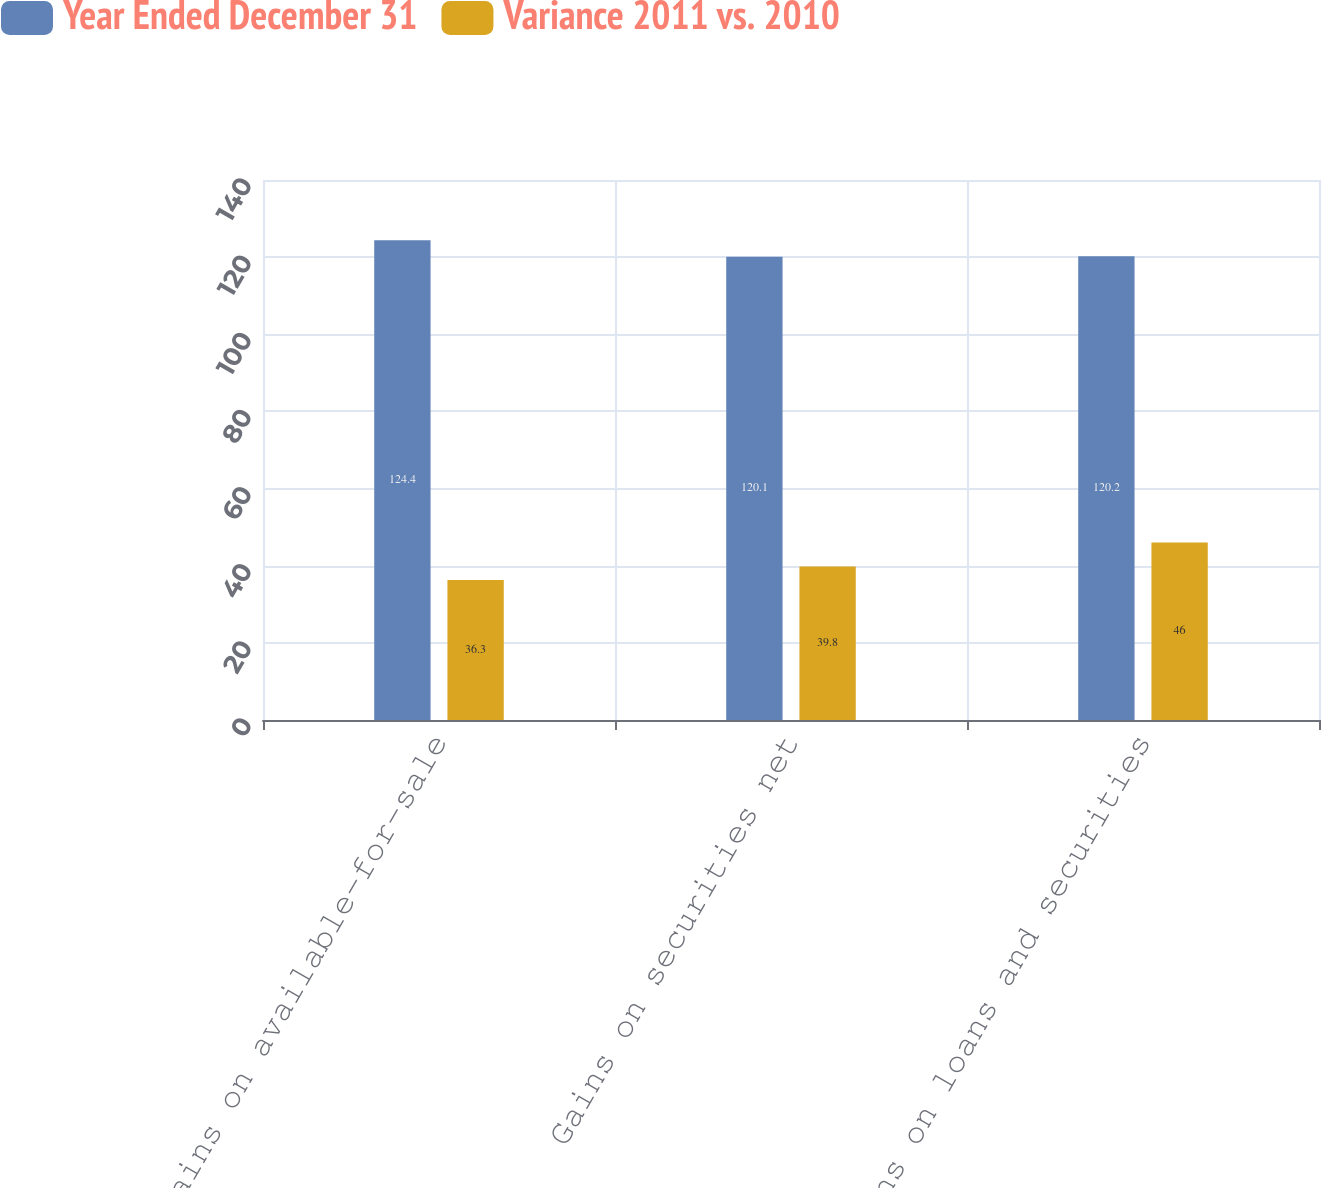<chart> <loc_0><loc_0><loc_500><loc_500><stacked_bar_chart><ecel><fcel>Gains on available-for-sale<fcel>Gains on securities net<fcel>Gains on loans and securities<nl><fcel>Year Ended December 31<fcel>124.4<fcel>120.1<fcel>120.2<nl><fcel>Variance 2011 vs. 2010<fcel>36.3<fcel>39.8<fcel>46<nl></chart> 